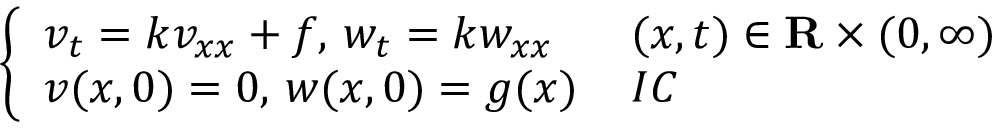<formula> <loc_0><loc_0><loc_500><loc_500>\left \{ \begin{array} { l l } { v _ { t } = k v _ { x x } + f , \, w _ { t } = k w _ { x x } \, } & { ( x , t ) \in R \times ( 0 , \infty ) } \\ { v ( x , 0 ) = 0 , \, w ( x , 0 ) = g ( x ) \, } & { I C } \end{array}</formula> 